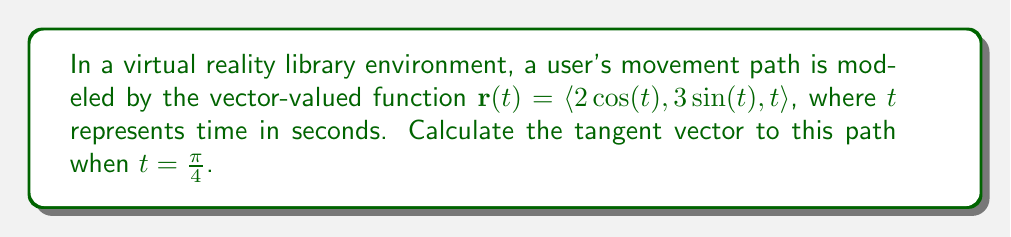Help me with this question. To find the tangent vector to the user's movement path, we need to follow these steps:

1) The tangent vector at any point on a curve defined by a vector-valued function $\mathbf{r}(t)$ is given by its derivative $\mathbf{r}'(t)$.

2) Let's calculate $\mathbf{r}'(t)$:

   $\mathbf{r}'(t) = \langle \frac{d}{dt}(2\cos(t)), \frac{d}{dt}(3\sin(t)), \frac{d}{dt}(t) \rangle$

3) Applying the derivative rules:
   
   $\mathbf{r}'(t) = \langle -2\sin(t), 3\cos(t), 1 \rangle$

4) Now, we need to evaluate this at $t = \frac{\pi}{4}$:

   $\mathbf{r}'(\frac{\pi}{4}) = \langle -2\sin(\frac{\pi}{4}), 3\cos(\frac{\pi}{4}), 1 \rangle$

5) Recall that $\sin(\frac{\pi}{4}) = \cos(\frac{\pi}{4}) = \frac{\sqrt{2}}{2}$:

   $\mathbf{r}'(\frac{\pi}{4}) = \langle -2(\frac{\sqrt{2}}{2}), 3(\frac{\sqrt{2}}{2}), 1 \rangle$

6) Simplify:

   $\mathbf{r}'(\frac{\pi}{4}) = \langle -\sqrt{2}, \frac{3\sqrt{2}}{2}, 1 \rangle$

This vector represents the tangent vector to the user's movement path at $t = \frac{\pi}{4}$.
Answer: The tangent vector to the user's movement path when $t = \frac{\pi}{4}$ is $\langle -\sqrt{2}, \frac{3\sqrt{2}}{2}, 1 \rangle$. 